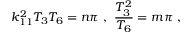<formula> <loc_0><loc_0><loc_500><loc_500>k _ { 1 1 } ^ { 2 } T _ { 3 } T _ { 6 } = n \pi \ , \ { \frac { T _ { 3 } ^ { 2 } } { T _ { 6 } } } = m \pi \ ,</formula> 